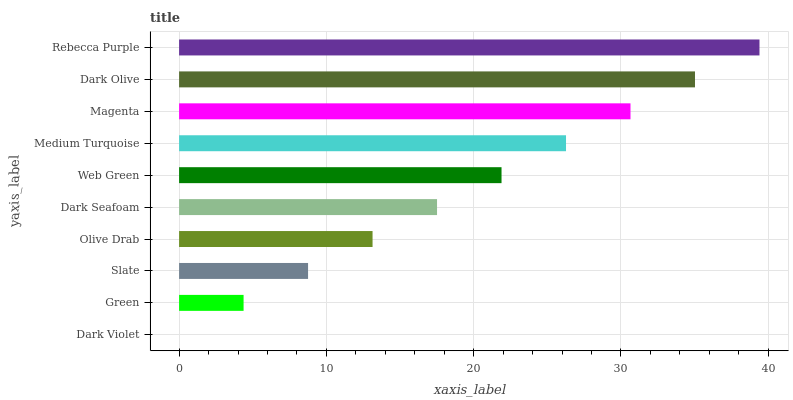Is Dark Violet the minimum?
Answer yes or no. Yes. Is Rebecca Purple the maximum?
Answer yes or no. Yes. Is Green the minimum?
Answer yes or no. No. Is Green the maximum?
Answer yes or no. No. Is Green greater than Dark Violet?
Answer yes or no. Yes. Is Dark Violet less than Green?
Answer yes or no. Yes. Is Dark Violet greater than Green?
Answer yes or no. No. Is Green less than Dark Violet?
Answer yes or no. No. Is Web Green the high median?
Answer yes or no. Yes. Is Dark Seafoam the low median?
Answer yes or no. Yes. Is Magenta the high median?
Answer yes or no. No. Is Olive Drab the low median?
Answer yes or no. No. 